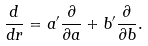Convert formula to latex. <formula><loc_0><loc_0><loc_500><loc_500>\frac { d } { d r } = a ^ { \prime } \frac { \partial } { \partial a } + b ^ { \prime } \frac { \partial } { \partial b } .</formula> 